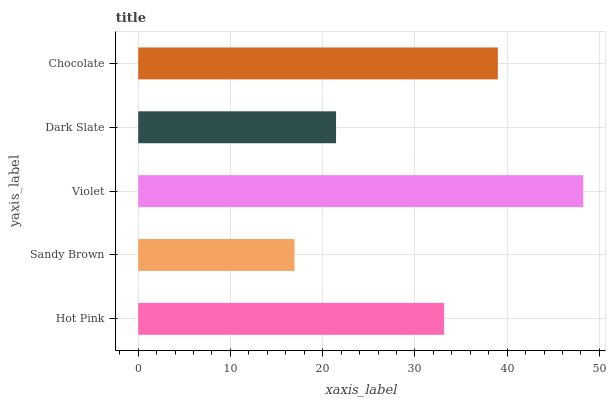Is Sandy Brown the minimum?
Answer yes or no. Yes. Is Violet the maximum?
Answer yes or no. Yes. Is Violet the minimum?
Answer yes or no. No. Is Sandy Brown the maximum?
Answer yes or no. No. Is Violet greater than Sandy Brown?
Answer yes or no. Yes. Is Sandy Brown less than Violet?
Answer yes or no. Yes. Is Sandy Brown greater than Violet?
Answer yes or no. No. Is Violet less than Sandy Brown?
Answer yes or no. No. Is Hot Pink the high median?
Answer yes or no. Yes. Is Hot Pink the low median?
Answer yes or no. Yes. Is Sandy Brown the high median?
Answer yes or no. No. Is Violet the low median?
Answer yes or no. No. 